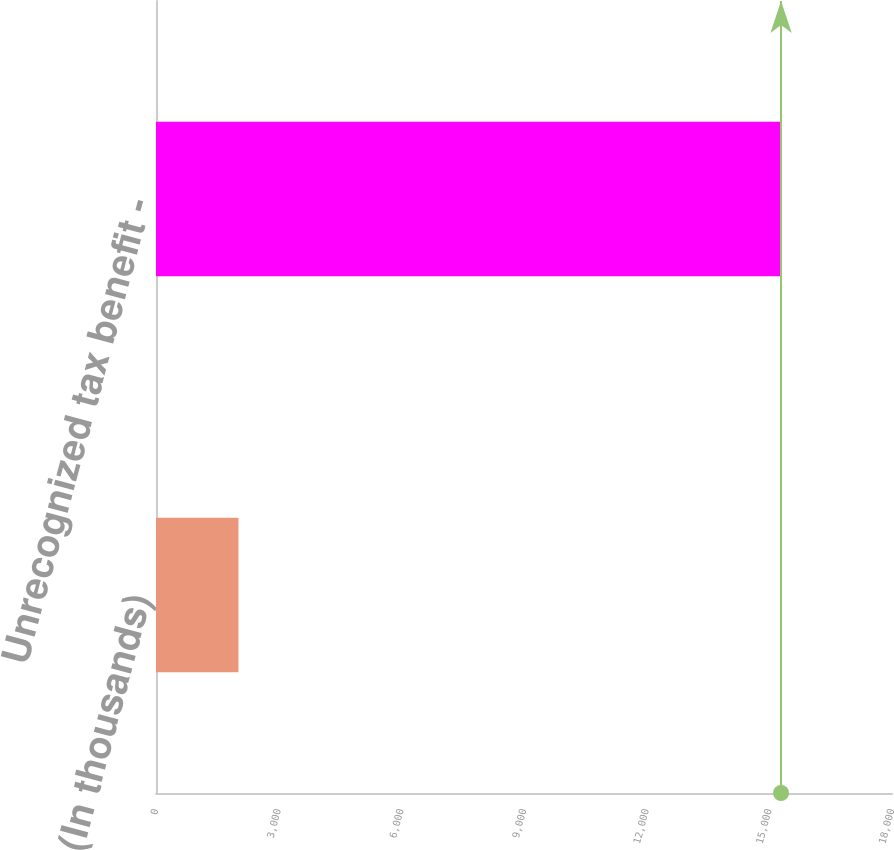Convert chart to OTSL. <chart><loc_0><loc_0><loc_500><loc_500><bar_chart><fcel>(In thousands)<fcel>Unrecognized tax benefit -<nl><fcel>2017<fcel>15287<nl></chart> 